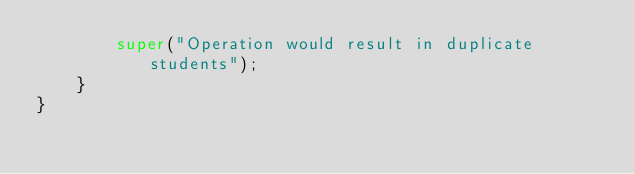Convert code to text. <code><loc_0><loc_0><loc_500><loc_500><_Java_>        super("Operation would result in duplicate students");
    }
}
</code> 